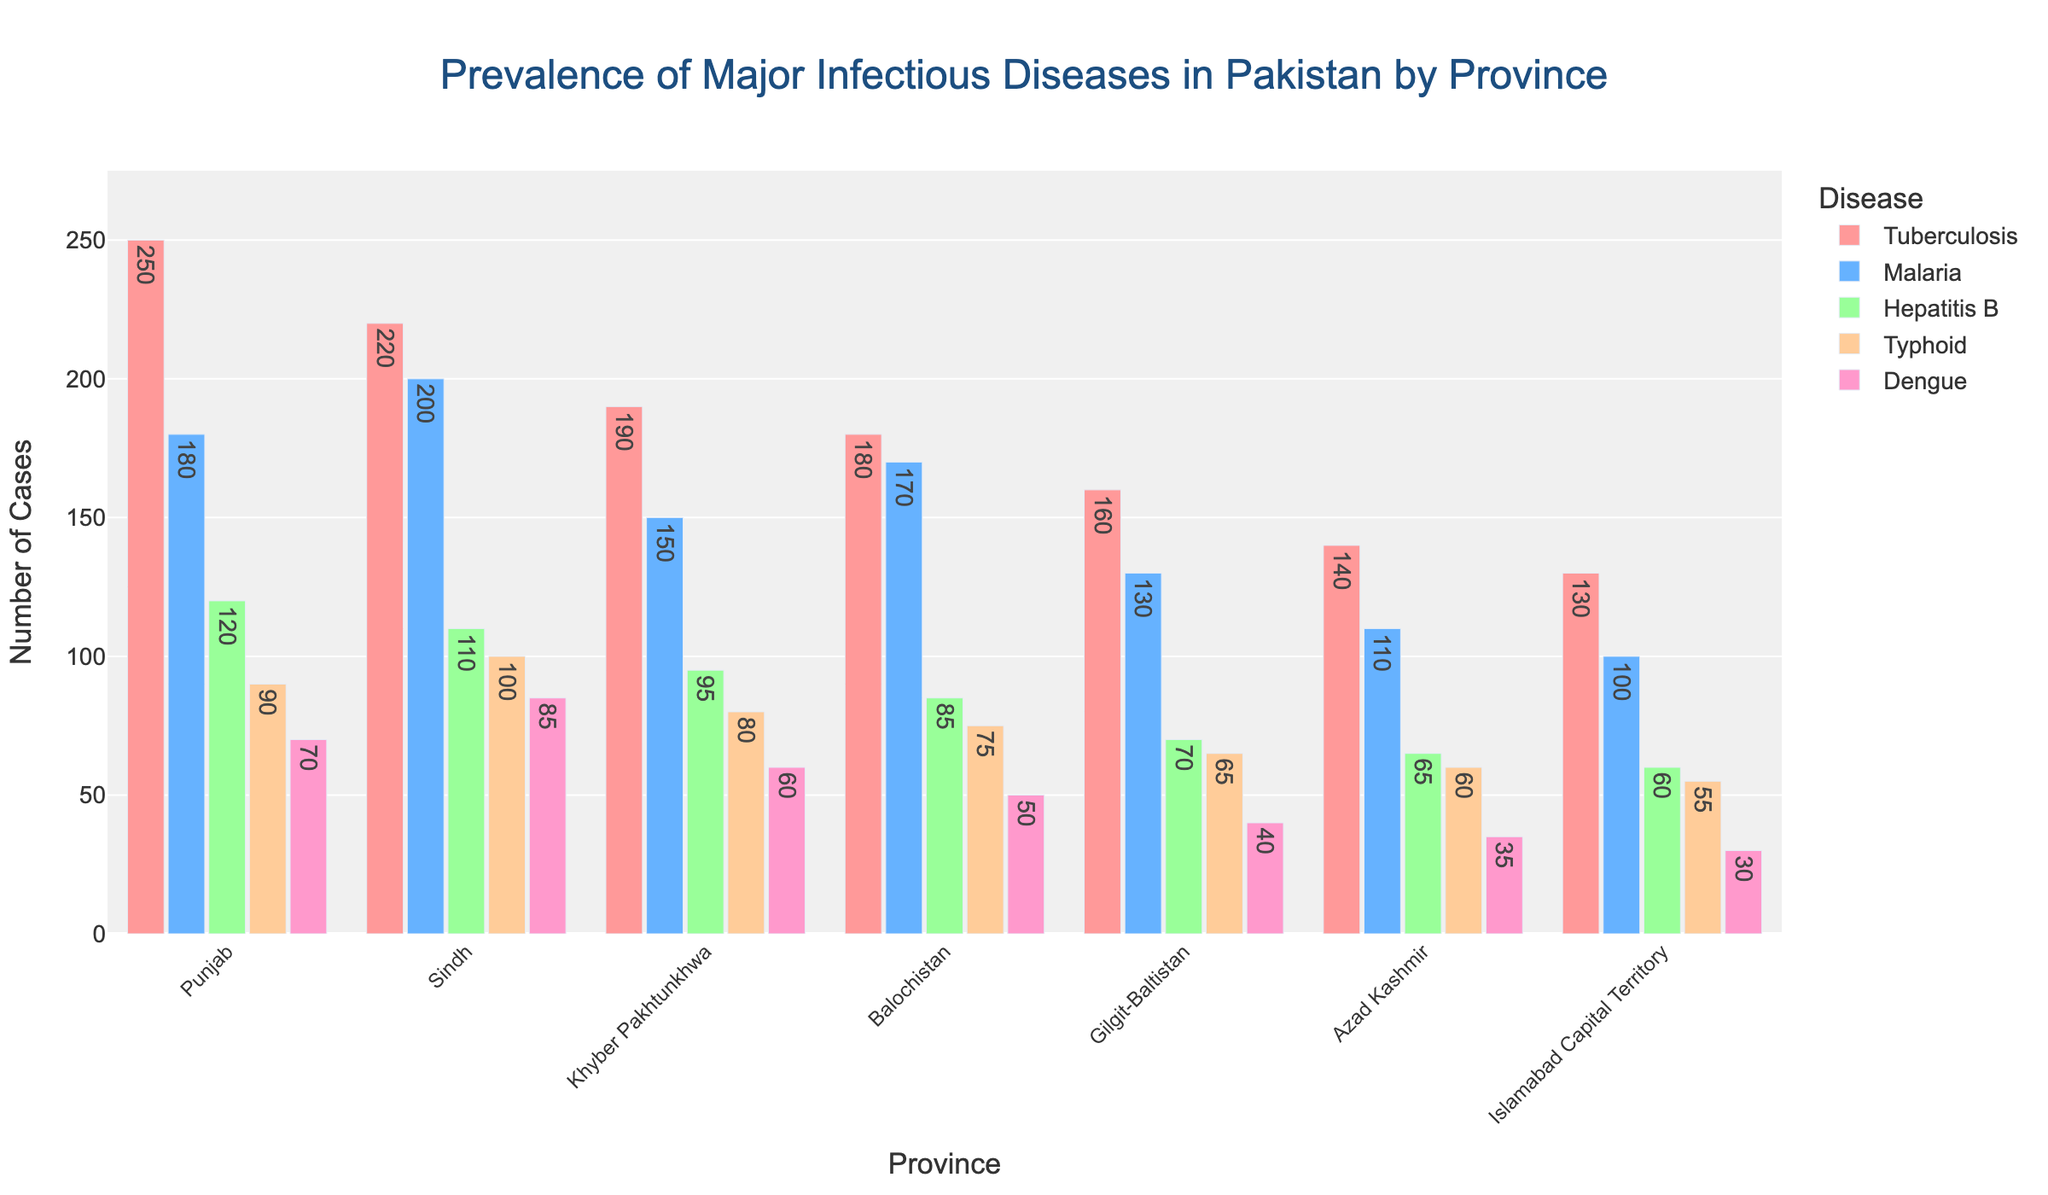What is the total number of tuberculosis cases in all provinces? To find the total number of tuberculosis cases, add the values for all provinces: 250 + 220 + 190 + 180 + 160 + 140 + 130 = 1270
Answer: 1270 Which province has the highest number of dengue cases? Look at the height of the bars corresponding to dengue cases, and identify which one is the tallest. In this case, Sindh has the tallest bar for dengue cases with 85 cases.
Answer: Sindh Compare the number of malaria cases between Punjab and Balochistan. Which province has more cases and by how much? Punjab has 180 malaria cases, and Balochistan has 170 malaria cases. The difference is 180 - 170 = 10. Therefore, Punjab has more malaria cases by 10.
Answer: Punjab, 10 What is the average number of typhoid cases across all provinces? Add up the number of typhoid cases for all provinces and divide by the number of provinces: (90 + 100 + 80 + 75 + 65 + 60 + 55) / 7 ≈ 75.71
Answer: 75.71 Which disease has the least prevalence in Gilgit-Baltistan and Azad Kashmir? Compare the heights of the bars for each disease within Gilgit-Baltistan and Azad Kashmir. For Gilgit-Baltistan, dengue has 40 cases, the least. For Azad Kashmir, dengue has 35 cases, the least.
Answer: Dengue How many more tuberculosis cases are there in Punjab compared to Sindh? Subtract the number of tuberculosis cases in Sindh from those in Punjab: 250 - 220 = 30
Answer: 30 What is the combined number of hepatitis B and typhoid cases in Khyber Pakhtunkhwa? Add up the values of hepatitis B and typhoid cases in Khyber Pakhtunkhwa: 95 + 80 = 175
Answer: 175 If you rank the provinces by the number of tuberculosis cases, which province is third? The order is Punjab (250), Sindh (220), Khyber Pakhtunkhwa (190), Balochistan (180), Gilgit-Baltistan (160), Azad Kashmir (140), and Islamabad (130). The third highest is Khyber Pakhtunkhwa with 190 cases.
Answer: Khyber Pakhtunkhwa What is the difference in the number of hepatitis B cases between Islamabad Capital Territory and Balochistan? Subtract the number of hepatitis B cases in Islamabad Capital Territory from those in Balochistan: 85 - 60 = 25
Answer: 25 Which province shows the lowest prevalence of malaria? Compare the heights of the bars representing malaria cases. Islamabad Capital Territory has the lowest number of malaria cases with 100 cases.
Answer: Islamabad Capital Territory 